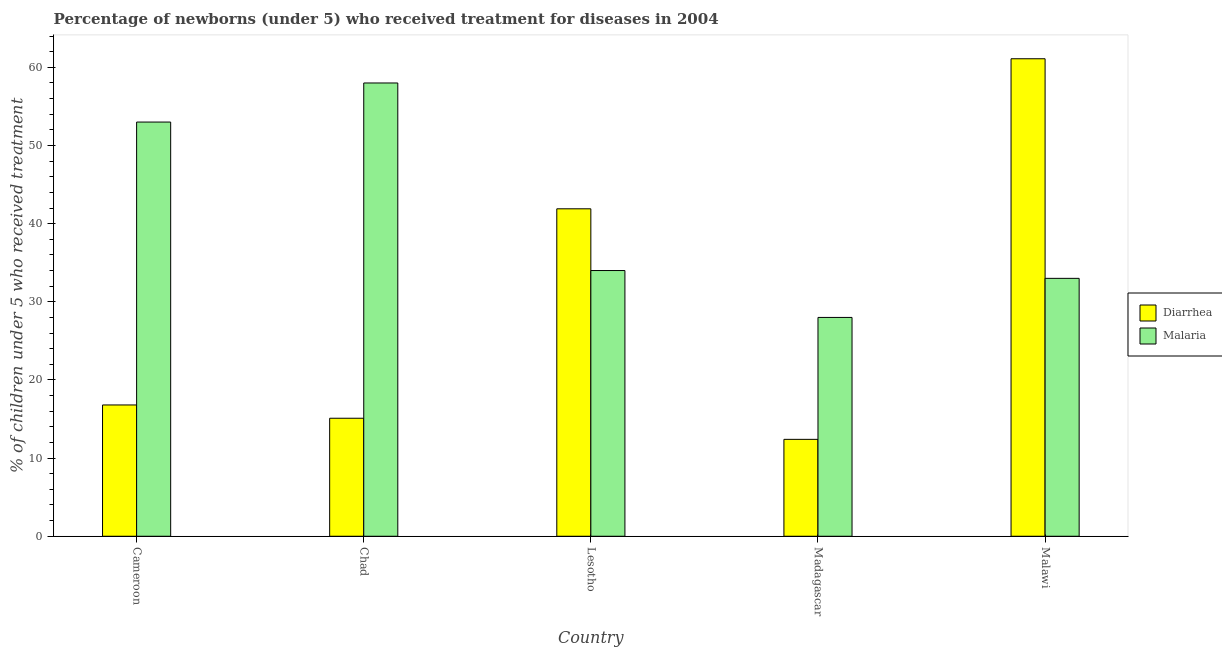How many groups of bars are there?
Keep it short and to the point. 5. Are the number of bars on each tick of the X-axis equal?
Ensure brevity in your answer.  Yes. How many bars are there on the 5th tick from the right?
Your answer should be compact. 2. What is the label of the 3rd group of bars from the left?
Give a very brief answer. Lesotho. What is the percentage of children who received treatment for diarrhoea in Malawi?
Keep it short and to the point. 61.1. Across all countries, what is the maximum percentage of children who received treatment for diarrhoea?
Ensure brevity in your answer.  61.1. Across all countries, what is the minimum percentage of children who received treatment for diarrhoea?
Provide a succinct answer. 12.4. In which country was the percentage of children who received treatment for malaria maximum?
Ensure brevity in your answer.  Chad. In which country was the percentage of children who received treatment for malaria minimum?
Provide a short and direct response. Madagascar. What is the total percentage of children who received treatment for diarrhoea in the graph?
Give a very brief answer. 147.3. What is the difference between the percentage of children who received treatment for malaria in Chad and that in Lesotho?
Your response must be concise. 24. What is the difference between the percentage of children who received treatment for malaria in Chad and the percentage of children who received treatment for diarrhoea in Cameroon?
Provide a succinct answer. 41.2. What is the average percentage of children who received treatment for diarrhoea per country?
Provide a short and direct response. 29.46. What is the difference between the percentage of children who received treatment for diarrhoea and percentage of children who received treatment for malaria in Chad?
Ensure brevity in your answer.  -42.9. What is the ratio of the percentage of children who received treatment for malaria in Cameroon to that in Lesotho?
Offer a terse response. 1.56. What is the difference between the highest and the second highest percentage of children who received treatment for diarrhoea?
Offer a terse response. 19.2. What is the difference between the highest and the lowest percentage of children who received treatment for diarrhoea?
Ensure brevity in your answer.  48.7. What does the 1st bar from the left in Lesotho represents?
Your answer should be compact. Diarrhea. What does the 2nd bar from the right in Madagascar represents?
Provide a succinct answer. Diarrhea. Are all the bars in the graph horizontal?
Keep it short and to the point. No. What is the difference between two consecutive major ticks on the Y-axis?
Give a very brief answer. 10. Are the values on the major ticks of Y-axis written in scientific E-notation?
Make the answer very short. No. Does the graph contain grids?
Provide a short and direct response. No. How many legend labels are there?
Make the answer very short. 2. How are the legend labels stacked?
Offer a terse response. Vertical. What is the title of the graph?
Provide a short and direct response. Percentage of newborns (under 5) who received treatment for diseases in 2004. What is the label or title of the X-axis?
Provide a succinct answer. Country. What is the label or title of the Y-axis?
Give a very brief answer. % of children under 5 who received treatment. What is the % of children under 5 who received treatment of Diarrhea in Lesotho?
Give a very brief answer. 41.9. What is the % of children under 5 who received treatment in Diarrhea in Malawi?
Offer a terse response. 61.1. What is the % of children under 5 who received treatment in Malaria in Malawi?
Offer a terse response. 33. Across all countries, what is the maximum % of children under 5 who received treatment of Diarrhea?
Make the answer very short. 61.1. Across all countries, what is the minimum % of children under 5 who received treatment in Diarrhea?
Make the answer very short. 12.4. What is the total % of children under 5 who received treatment in Diarrhea in the graph?
Ensure brevity in your answer.  147.3. What is the total % of children under 5 who received treatment in Malaria in the graph?
Ensure brevity in your answer.  206. What is the difference between the % of children under 5 who received treatment in Malaria in Cameroon and that in Chad?
Make the answer very short. -5. What is the difference between the % of children under 5 who received treatment in Diarrhea in Cameroon and that in Lesotho?
Offer a terse response. -25.1. What is the difference between the % of children under 5 who received treatment in Diarrhea in Cameroon and that in Madagascar?
Provide a succinct answer. 4.4. What is the difference between the % of children under 5 who received treatment in Malaria in Cameroon and that in Madagascar?
Give a very brief answer. 25. What is the difference between the % of children under 5 who received treatment in Diarrhea in Cameroon and that in Malawi?
Provide a succinct answer. -44.3. What is the difference between the % of children under 5 who received treatment of Diarrhea in Chad and that in Lesotho?
Provide a short and direct response. -26.8. What is the difference between the % of children under 5 who received treatment in Diarrhea in Chad and that in Madagascar?
Provide a short and direct response. 2.7. What is the difference between the % of children under 5 who received treatment in Diarrhea in Chad and that in Malawi?
Keep it short and to the point. -46. What is the difference between the % of children under 5 who received treatment in Malaria in Chad and that in Malawi?
Your response must be concise. 25. What is the difference between the % of children under 5 who received treatment of Diarrhea in Lesotho and that in Madagascar?
Offer a terse response. 29.5. What is the difference between the % of children under 5 who received treatment in Diarrhea in Lesotho and that in Malawi?
Your answer should be very brief. -19.2. What is the difference between the % of children under 5 who received treatment in Diarrhea in Madagascar and that in Malawi?
Provide a short and direct response. -48.7. What is the difference between the % of children under 5 who received treatment in Diarrhea in Cameroon and the % of children under 5 who received treatment in Malaria in Chad?
Give a very brief answer. -41.2. What is the difference between the % of children under 5 who received treatment of Diarrhea in Cameroon and the % of children under 5 who received treatment of Malaria in Lesotho?
Make the answer very short. -17.2. What is the difference between the % of children under 5 who received treatment of Diarrhea in Cameroon and the % of children under 5 who received treatment of Malaria in Madagascar?
Make the answer very short. -11.2. What is the difference between the % of children under 5 who received treatment in Diarrhea in Cameroon and the % of children under 5 who received treatment in Malaria in Malawi?
Your answer should be very brief. -16.2. What is the difference between the % of children under 5 who received treatment in Diarrhea in Chad and the % of children under 5 who received treatment in Malaria in Lesotho?
Provide a succinct answer. -18.9. What is the difference between the % of children under 5 who received treatment of Diarrhea in Chad and the % of children under 5 who received treatment of Malaria in Malawi?
Make the answer very short. -17.9. What is the difference between the % of children under 5 who received treatment of Diarrhea in Madagascar and the % of children under 5 who received treatment of Malaria in Malawi?
Your answer should be compact. -20.6. What is the average % of children under 5 who received treatment in Diarrhea per country?
Your answer should be very brief. 29.46. What is the average % of children under 5 who received treatment of Malaria per country?
Offer a terse response. 41.2. What is the difference between the % of children under 5 who received treatment in Diarrhea and % of children under 5 who received treatment in Malaria in Cameroon?
Keep it short and to the point. -36.2. What is the difference between the % of children under 5 who received treatment in Diarrhea and % of children under 5 who received treatment in Malaria in Chad?
Provide a short and direct response. -42.9. What is the difference between the % of children under 5 who received treatment in Diarrhea and % of children under 5 who received treatment in Malaria in Madagascar?
Ensure brevity in your answer.  -15.6. What is the difference between the % of children under 5 who received treatment in Diarrhea and % of children under 5 who received treatment in Malaria in Malawi?
Give a very brief answer. 28.1. What is the ratio of the % of children under 5 who received treatment in Diarrhea in Cameroon to that in Chad?
Make the answer very short. 1.11. What is the ratio of the % of children under 5 who received treatment in Malaria in Cameroon to that in Chad?
Your response must be concise. 0.91. What is the ratio of the % of children under 5 who received treatment of Diarrhea in Cameroon to that in Lesotho?
Ensure brevity in your answer.  0.4. What is the ratio of the % of children under 5 who received treatment in Malaria in Cameroon to that in Lesotho?
Ensure brevity in your answer.  1.56. What is the ratio of the % of children under 5 who received treatment of Diarrhea in Cameroon to that in Madagascar?
Provide a short and direct response. 1.35. What is the ratio of the % of children under 5 who received treatment in Malaria in Cameroon to that in Madagascar?
Offer a very short reply. 1.89. What is the ratio of the % of children under 5 who received treatment of Diarrhea in Cameroon to that in Malawi?
Your answer should be very brief. 0.28. What is the ratio of the % of children under 5 who received treatment of Malaria in Cameroon to that in Malawi?
Make the answer very short. 1.61. What is the ratio of the % of children under 5 who received treatment of Diarrhea in Chad to that in Lesotho?
Your response must be concise. 0.36. What is the ratio of the % of children under 5 who received treatment of Malaria in Chad to that in Lesotho?
Your response must be concise. 1.71. What is the ratio of the % of children under 5 who received treatment in Diarrhea in Chad to that in Madagascar?
Make the answer very short. 1.22. What is the ratio of the % of children under 5 who received treatment in Malaria in Chad to that in Madagascar?
Give a very brief answer. 2.07. What is the ratio of the % of children under 5 who received treatment in Diarrhea in Chad to that in Malawi?
Offer a very short reply. 0.25. What is the ratio of the % of children under 5 who received treatment of Malaria in Chad to that in Malawi?
Your response must be concise. 1.76. What is the ratio of the % of children under 5 who received treatment in Diarrhea in Lesotho to that in Madagascar?
Provide a short and direct response. 3.38. What is the ratio of the % of children under 5 who received treatment in Malaria in Lesotho to that in Madagascar?
Provide a succinct answer. 1.21. What is the ratio of the % of children under 5 who received treatment in Diarrhea in Lesotho to that in Malawi?
Ensure brevity in your answer.  0.69. What is the ratio of the % of children under 5 who received treatment of Malaria in Lesotho to that in Malawi?
Offer a very short reply. 1.03. What is the ratio of the % of children under 5 who received treatment of Diarrhea in Madagascar to that in Malawi?
Offer a very short reply. 0.2. What is the ratio of the % of children under 5 who received treatment in Malaria in Madagascar to that in Malawi?
Provide a succinct answer. 0.85. What is the difference between the highest and the second highest % of children under 5 who received treatment of Diarrhea?
Your answer should be very brief. 19.2. What is the difference between the highest and the lowest % of children under 5 who received treatment of Diarrhea?
Your answer should be compact. 48.7. What is the difference between the highest and the lowest % of children under 5 who received treatment in Malaria?
Ensure brevity in your answer.  30. 